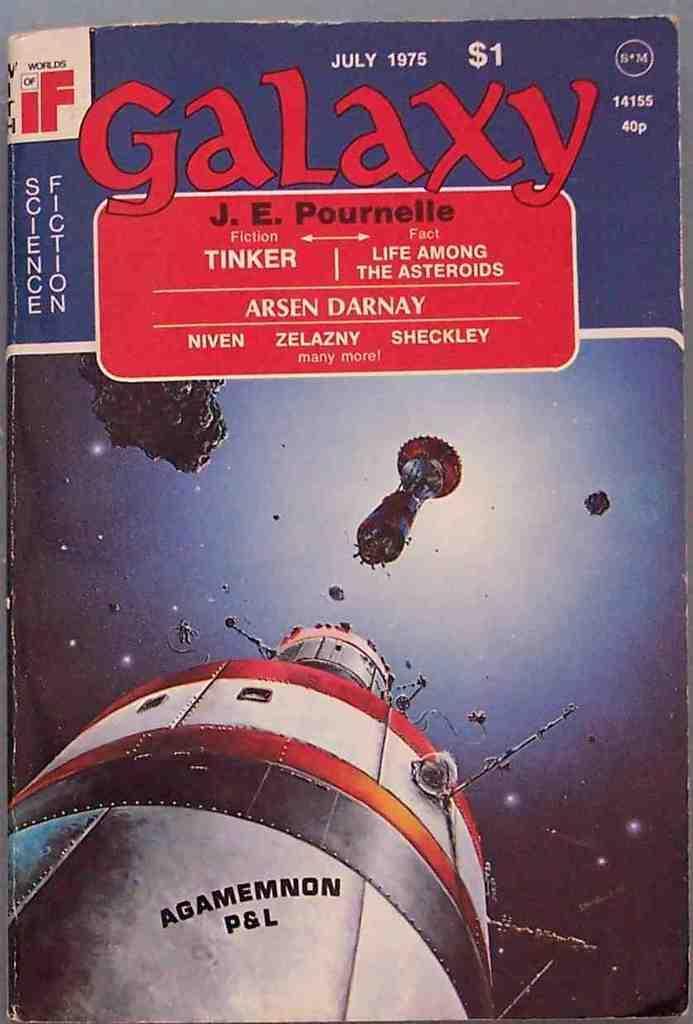Could you give a brief overview of what you see in this image? This is a poster and in this poster we can see some text and objects. 